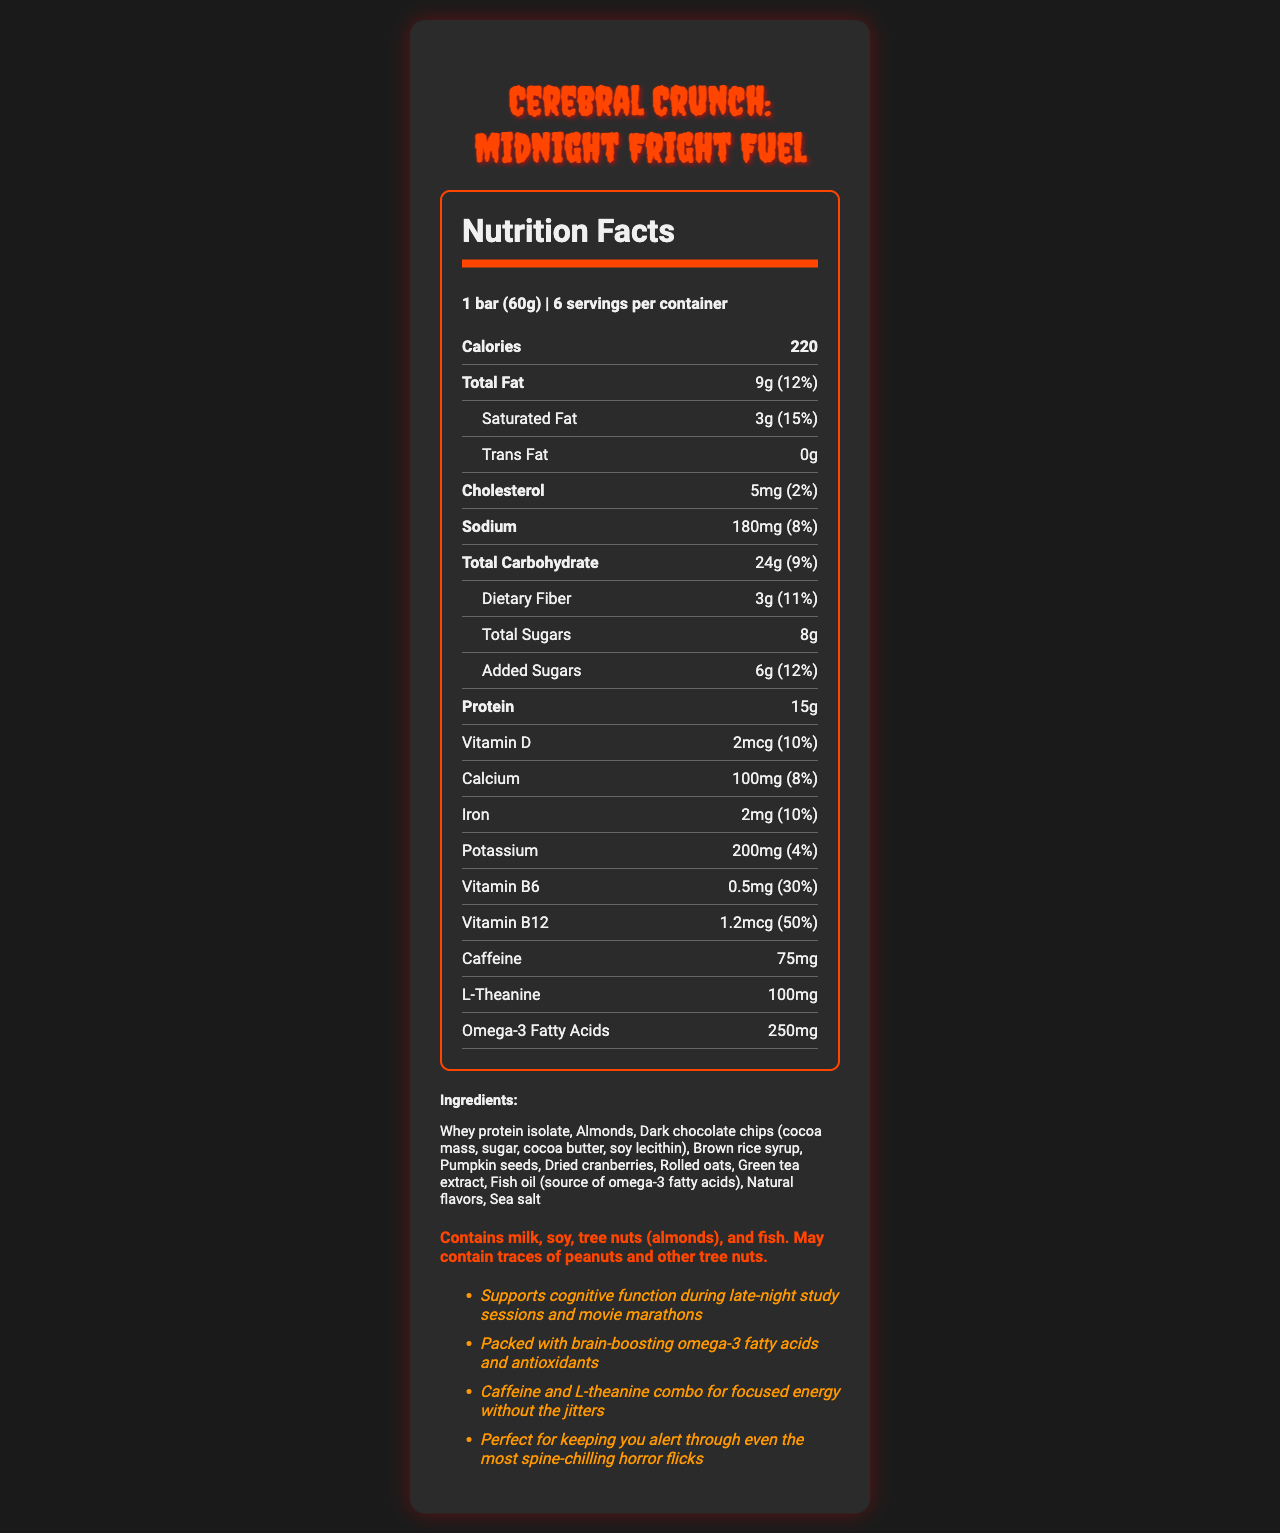how many calories are there in one serving of Cerebral Crunch: Midnight Fright Fuel? The document states that each serving of the protein bar contains 220 calories.
Answer: 220 what is the serving size of the protein bar? The document mentions that the serving size is 1 bar weighing 60 grams.
Answer: 1 bar (60g) how many grams of protein does one bar contain? The nutrition information indicates that one bar contains 15 grams of protein.
Answer: 15g what is the total fat content per serving? The document specifies that each serving has a total fat content of 9 grams.
Answer: 9g what vitamins are listed in the nutrition facts? The document lists Vitamin D, Vitamin B6, and Vitamin B12 in the nutrition facts section.
Answer: Vitamin D, Vitamin B6, Vitamin B12 how much caffeine does each bar contain? The document states that each bar contains 75mg of caffeine.
Answer: 75mg which ingredient is a source of omega-3 fatty acids? The ingredient list specifies that fish oil is the source of omega-3 fatty acids.
Answer: Fish oil how much of the daily value of saturated fat does one bar provide? According to the nutrition information, one bar provides 15% of the daily value of saturated fat.
Answer: 15% how many servings are in one container? The document states that there are 6 servings per container.
Answer: 6 which of the following is not included in the bar's ingredients? A. Almonds B. Whey Protein Isolate C. Peanut Butter D. Green Tea Extract Peanut butter is not listed among the ingredients.
Answer: C how much dietary fiber is in a single serving? A. 2g B. 3g C. 4g D. 5g The document indicates that a single serving contains 3 grams of dietary fiber.
Answer: B is there any trans fat in one serving of this protein bar? The document shows that the trans fat content is 0g, indicating there is no trans fat in one serving.
Answer: No what is the percentage of the daily value for Vitamin B12 in one bar? The document specifies that one bar provides 50% of the daily value for Vitamin B12.
Answer: 50% how does the marketing claim describe the combination of caffeine and L-theanine? According to the marketing claims, the combination of caffeine and L-theanine is described as providing focused energy without the jitters.
Answer: Focused energy without the jitters what allergens are listed in the allergen information? The allergen information section lists milk, soy, tree nuts (almonds), and fish as allergies present in the product.
Answer: Milk, soy, tree nuts (almonds), and fish what is the main idea of the document? The document primarily aims to present the nutritional facts and ingredients of the protein bar while promoting its specific benefits for cognitive function, energy, and suitability for late-night study sessions and horror movie marathons.
Answer: The document provides detailed nutritional information for the Cerebral Crunch: Midnight Fright Fuel protein bar, highlighting its ingredients, serving size, calorie content, and various nutrients, while also promoting its benefits for cognitive function, brain health, and focused energy during late-night activities. what ingredient provides the chocolate flavor in the protein bar? The document lists "Dark chocolate chips (cocoa mass, sugar, cocoa butter, soy lecithin)" as an ingredient, indicating multiple components, but does not specify which component provides the chocolate flavor.
Answer: Cannot be determined which vitamin is present in the highest percentage of the daily value? A. Vitamin D B. Vitamin B6 C. Vitamin B12 D. Iron Vitamin B12 is present at 50% of the daily value, which is higher than any other listed vitamin or nutrient.
Answer: C 